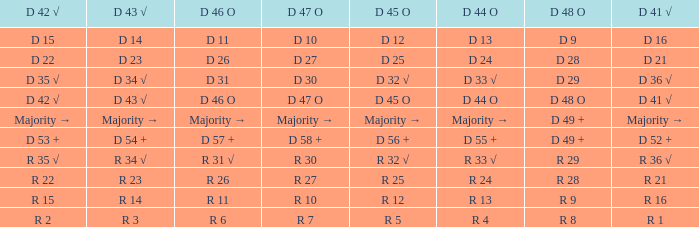Name the D 45 O with D 44 O majority → Majority →. 